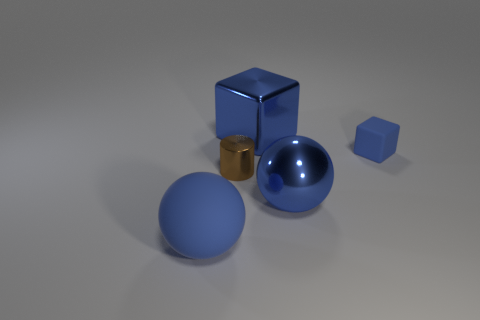What is the shape of the tiny object that is the same color as the big shiny block?
Your answer should be very brief. Cube. What is the size of the matte block that is the same color as the big rubber thing?
Make the answer very short. Small. What is the material of the tiny object that is right of the big thing that is behind the tiny matte object?
Your response must be concise. Rubber. What is the size of the blue thing that is in front of the blue sphere behind the thing on the left side of the brown cylinder?
Ensure brevity in your answer.  Large. How many brown cylinders have the same material as the big blue block?
Your response must be concise. 1. There is a big shiny object right of the block behind the tiny blue matte object; what color is it?
Offer a terse response. Blue. How many objects are either tiny blue matte objects or large blue shiny things in front of the small blue cube?
Give a very brief answer. 2. Are there any large metal balls of the same color as the tiny cylinder?
Make the answer very short. No. How many blue objects are either shiny cubes or large balls?
Provide a succinct answer. 3. How many other things are there of the same size as the metallic cylinder?
Offer a very short reply. 1. 